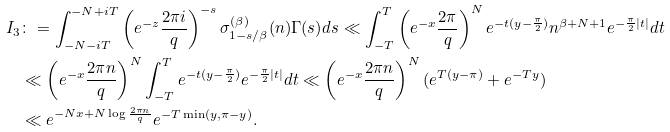Convert formula to latex. <formula><loc_0><loc_0><loc_500><loc_500>I _ { 3 } & \colon = \int _ { - N - i T } ^ { - N + i T } \left ( e ^ { - z } \frac { 2 \pi i } { q } \right ) ^ { - s } \sigma _ { 1 - s / \beta } ^ { ( \beta ) } ( n ) \Gamma ( s ) d s \ll \int _ { - T } ^ { T } \left ( e ^ { - x } \frac { 2 \pi } { q } \right ) ^ { N } e ^ { - t ( y - \frac { \pi } { 2 } ) } n ^ { \beta + N + 1 } e ^ { - \frac { \pi } { 2 } | t | } d t \\ & \ll \left ( e ^ { - x } \frac { 2 \pi n } { q } \right ) ^ { N } \int _ { - T } ^ { T } e ^ { - t ( y - \frac { \pi } { 2 } ) } e ^ { - \frac { \pi } { 2 } | t | } d t \ll \left ( e ^ { - x } \frac { 2 \pi n } { q } \right ) ^ { N } ( e ^ { T ( y - \pi ) } + e ^ { - T y } ) \\ & \ll e ^ { - N x + N \log \frac { 2 \pi n } { q } } e ^ { - T \min ( y , \pi - y ) } .</formula> 